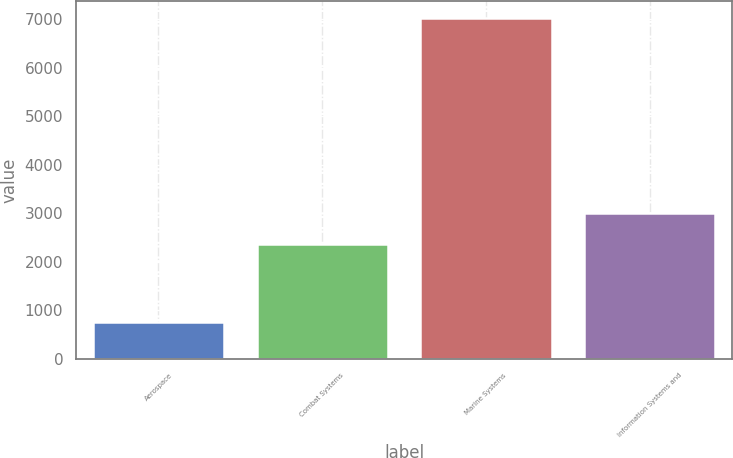<chart> <loc_0><loc_0><loc_500><loc_500><bar_chart><fcel>Aerospace<fcel>Combat Systems<fcel>Marine Systems<fcel>Information Systems and<nl><fcel>765<fcel>2374<fcel>7014<fcel>2998.9<nl></chart> 